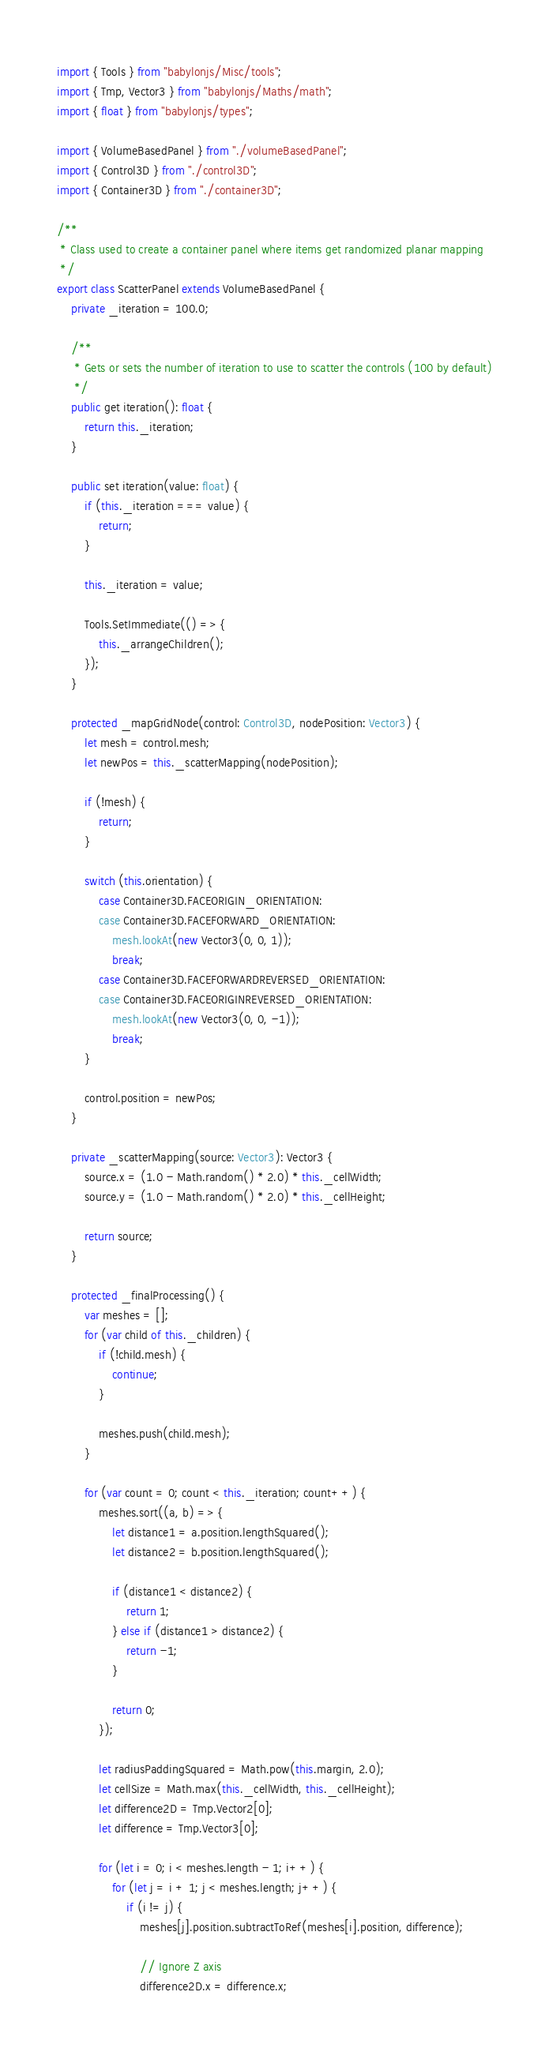<code> <loc_0><loc_0><loc_500><loc_500><_TypeScript_>import { Tools } from "babylonjs/Misc/tools";
import { Tmp, Vector3 } from "babylonjs/Maths/math";
import { float } from "babylonjs/types";

import { VolumeBasedPanel } from "./volumeBasedPanel";
import { Control3D } from "./control3D";
import { Container3D } from "./container3D";

/**
 * Class used to create a container panel where items get randomized planar mapping
 */
export class ScatterPanel extends VolumeBasedPanel {
    private _iteration = 100.0;

    /**
     * Gets or sets the number of iteration to use to scatter the controls (100 by default)
     */
    public get iteration(): float {
        return this._iteration;
    }

    public set iteration(value: float) {
        if (this._iteration === value) {
            return;
        }

        this._iteration = value;

        Tools.SetImmediate(() => {
            this._arrangeChildren();
        });
    }

    protected _mapGridNode(control: Control3D, nodePosition: Vector3) {
        let mesh = control.mesh;
        let newPos = this._scatterMapping(nodePosition);

        if (!mesh) {
            return;
        }

        switch (this.orientation) {
            case Container3D.FACEORIGIN_ORIENTATION:
            case Container3D.FACEFORWARD_ORIENTATION:
                mesh.lookAt(new Vector3(0, 0, 1));
                break;
            case Container3D.FACEFORWARDREVERSED_ORIENTATION:
            case Container3D.FACEORIGINREVERSED_ORIENTATION:
                mesh.lookAt(new Vector3(0, 0, -1));
                break;
        }

        control.position = newPos;
    }

    private _scatterMapping(source: Vector3): Vector3 {
        source.x = (1.0 - Math.random() * 2.0) * this._cellWidth;
        source.y = (1.0 - Math.random() * 2.0) * this._cellHeight;

        return source;
    }

    protected _finalProcessing() {
        var meshes = [];
        for (var child of this._children) {
            if (!child.mesh) {
                continue;
            }

            meshes.push(child.mesh);
        }

        for (var count = 0; count < this._iteration; count++) {
            meshes.sort((a, b) => {
                let distance1 = a.position.lengthSquared();
                let distance2 = b.position.lengthSquared();

                if (distance1 < distance2) {
                    return 1;
                } else if (distance1 > distance2) {
                    return -1;
                }

                return 0;
            });

            let radiusPaddingSquared = Math.pow(this.margin, 2.0);
            let cellSize = Math.max(this._cellWidth, this._cellHeight);
            let difference2D = Tmp.Vector2[0];
            let difference = Tmp.Vector3[0];

            for (let i = 0; i < meshes.length - 1; i++) {
                for (let j = i + 1; j < meshes.length; j++) {
                    if (i != j) {
                        meshes[j].position.subtractToRef(meshes[i].position, difference);

                        // Ignore Z axis
                        difference2D.x = difference.x;</code> 